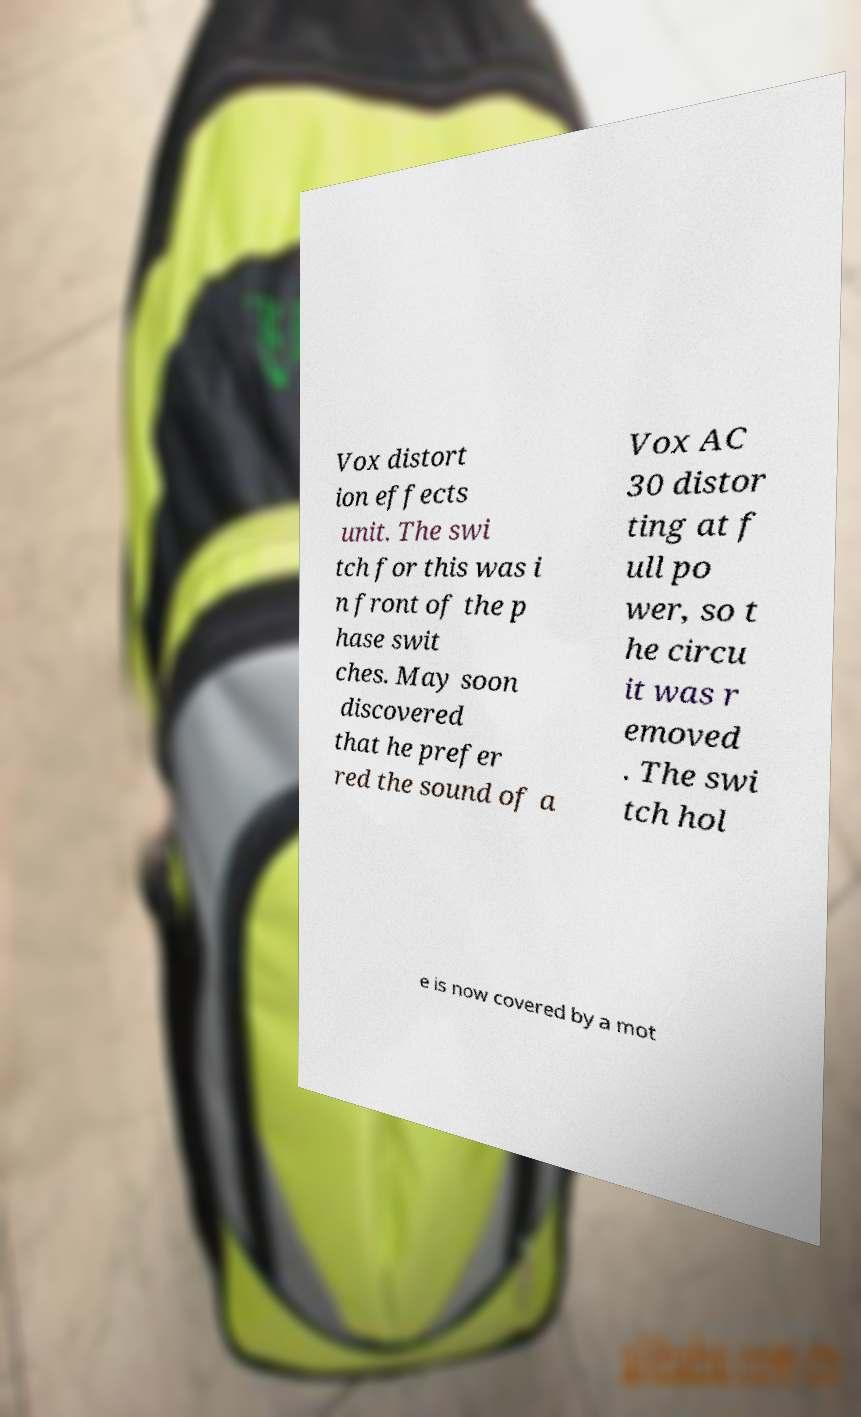Please read and relay the text visible in this image. What does it say? Vox distort ion effects unit. The swi tch for this was i n front of the p hase swit ches. May soon discovered that he prefer red the sound of a Vox AC 30 distor ting at f ull po wer, so t he circu it was r emoved . The swi tch hol e is now covered by a mot 